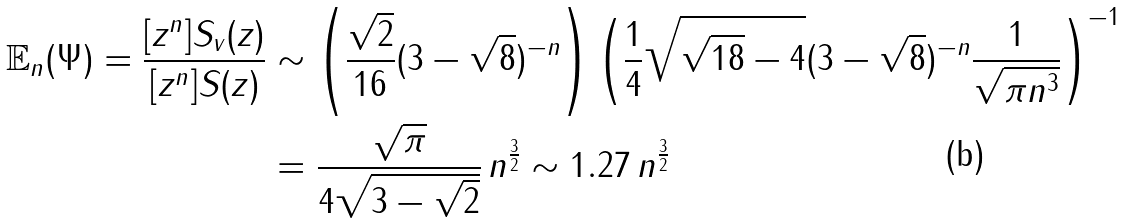<formula> <loc_0><loc_0><loc_500><loc_500>\mathbb { E } _ { n } ( \Psi ) = \frac { [ z ^ { n } ] S _ { v } ( z ) } { [ z ^ { n } ] S ( z ) } & \sim \left ( \frac { \sqrt { 2 } } { 1 6 } ( 3 - \sqrt { 8 } ) ^ { - n } \right ) \left ( \frac { 1 } { 4 } \sqrt { \sqrt { 1 8 } - 4 } ( 3 - \sqrt { 8 } ) ^ { - n } \frac { 1 } { \sqrt { \pi n ^ { 3 } } } \right ) ^ { - 1 } \\ & = \frac { \sqrt { \pi } } { 4 \sqrt { 3 - \sqrt { 2 } } } \, n ^ { \frac { 3 } { 2 } } \sim 1 . 2 7 \, n ^ { \frac { 3 } { 2 } }</formula> 